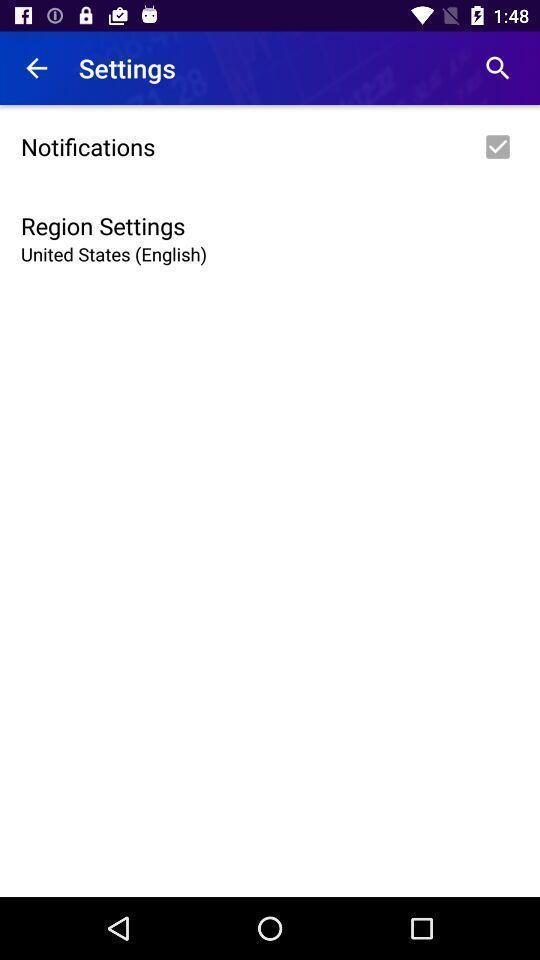Tell me about the visual elements in this screen capture. Settings page showing two parameters. 